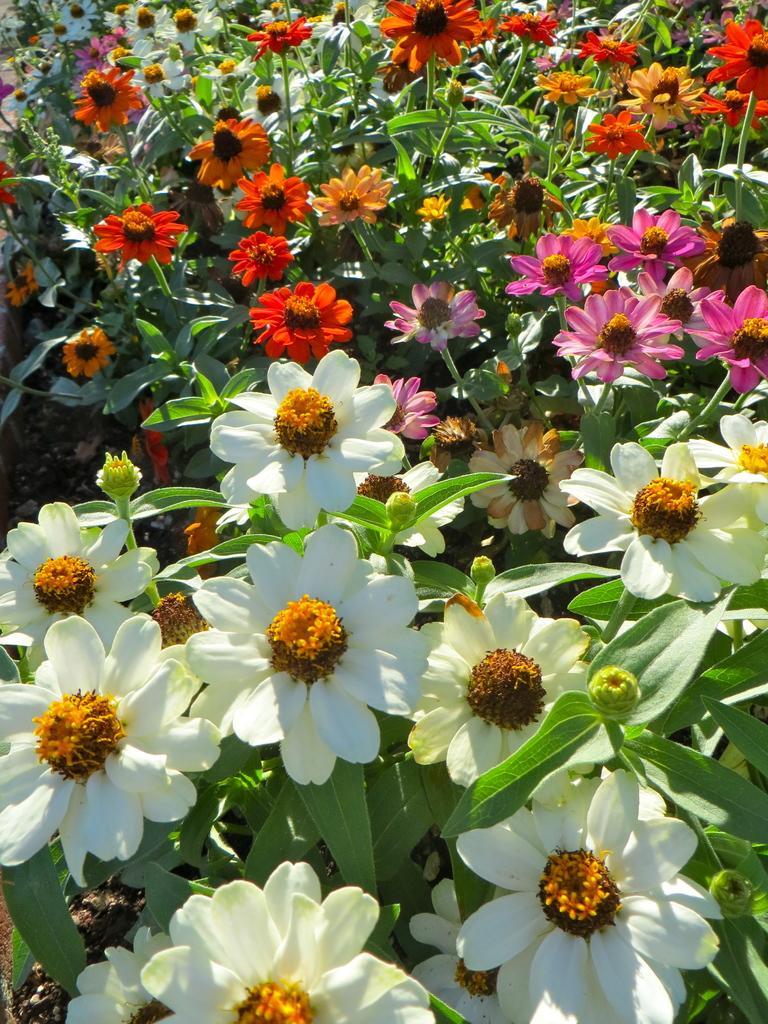Can you describe this image briefly? We can see colorful flowers,buds and plants. 